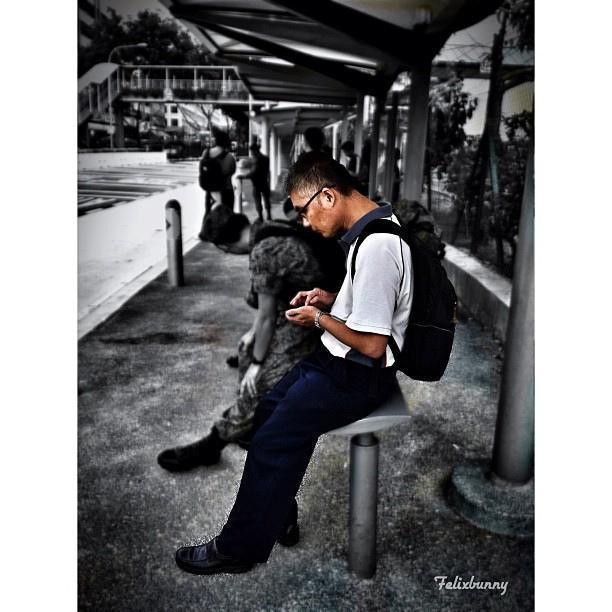Where is the man storing his things?
Pick the correct solution from the four options below to address the question.
Options: Suitcase, duffel bag, purse, backpack. Backpack. 